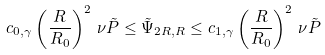<formula> <loc_0><loc_0><loc_500><loc_500>c _ { 0 , \gamma } \left ( \frac { R } { R _ { 0 } } \right ) ^ { 2 } \, \nu \tilde { P } \leq \tilde { \Psi } _ { 2 R , R } \leq c _ { 1 , \gamma } \left ( \frac { R } { R _ { 0 } } \right ) ^ { 2 } \, \nu \tilde { P } \,</formula> 